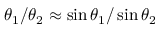<formula> <loc_0><loc_0><loc_500><loc_500>\theta _ { 1 } / \theta _ { 2 } \approx \sin \theta _ { 1 } / \sin \theta _ { 2 }</formula> 